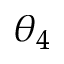Convert formula to latex. <formula><loc_0><loc_0><loc_500><loc_500>\theta _ { 4 }</formula> 